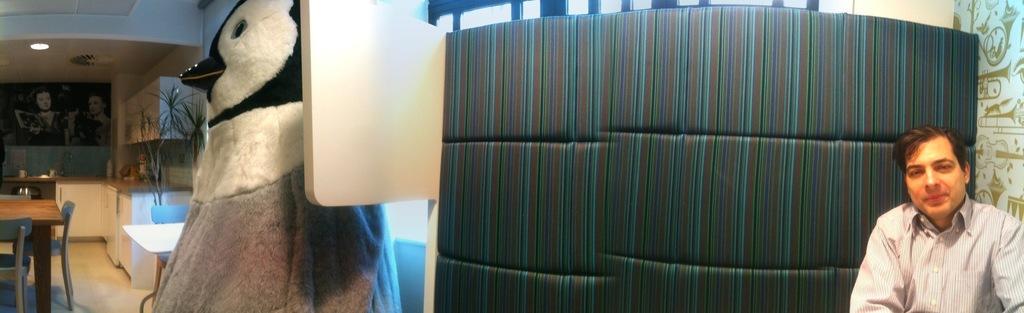In one or two sentences, can you explain what this image depicts? In this image we can see a man, toy, tables, chairs, cupboards, wash basin, plant, light, ceiling, and few objects. Here we can see pictures on the wall. 